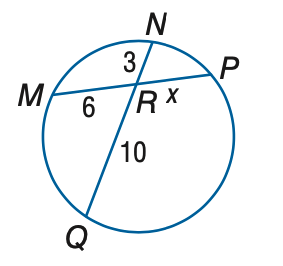Answer the mathemtical geometry problem and directly provide the correct option letter.
Question: Find x to the nearest tenth. Assume that segments that appear to be tangent are tangent.
Choices: A: 3 B: 4 C: 5 D: 6 C 